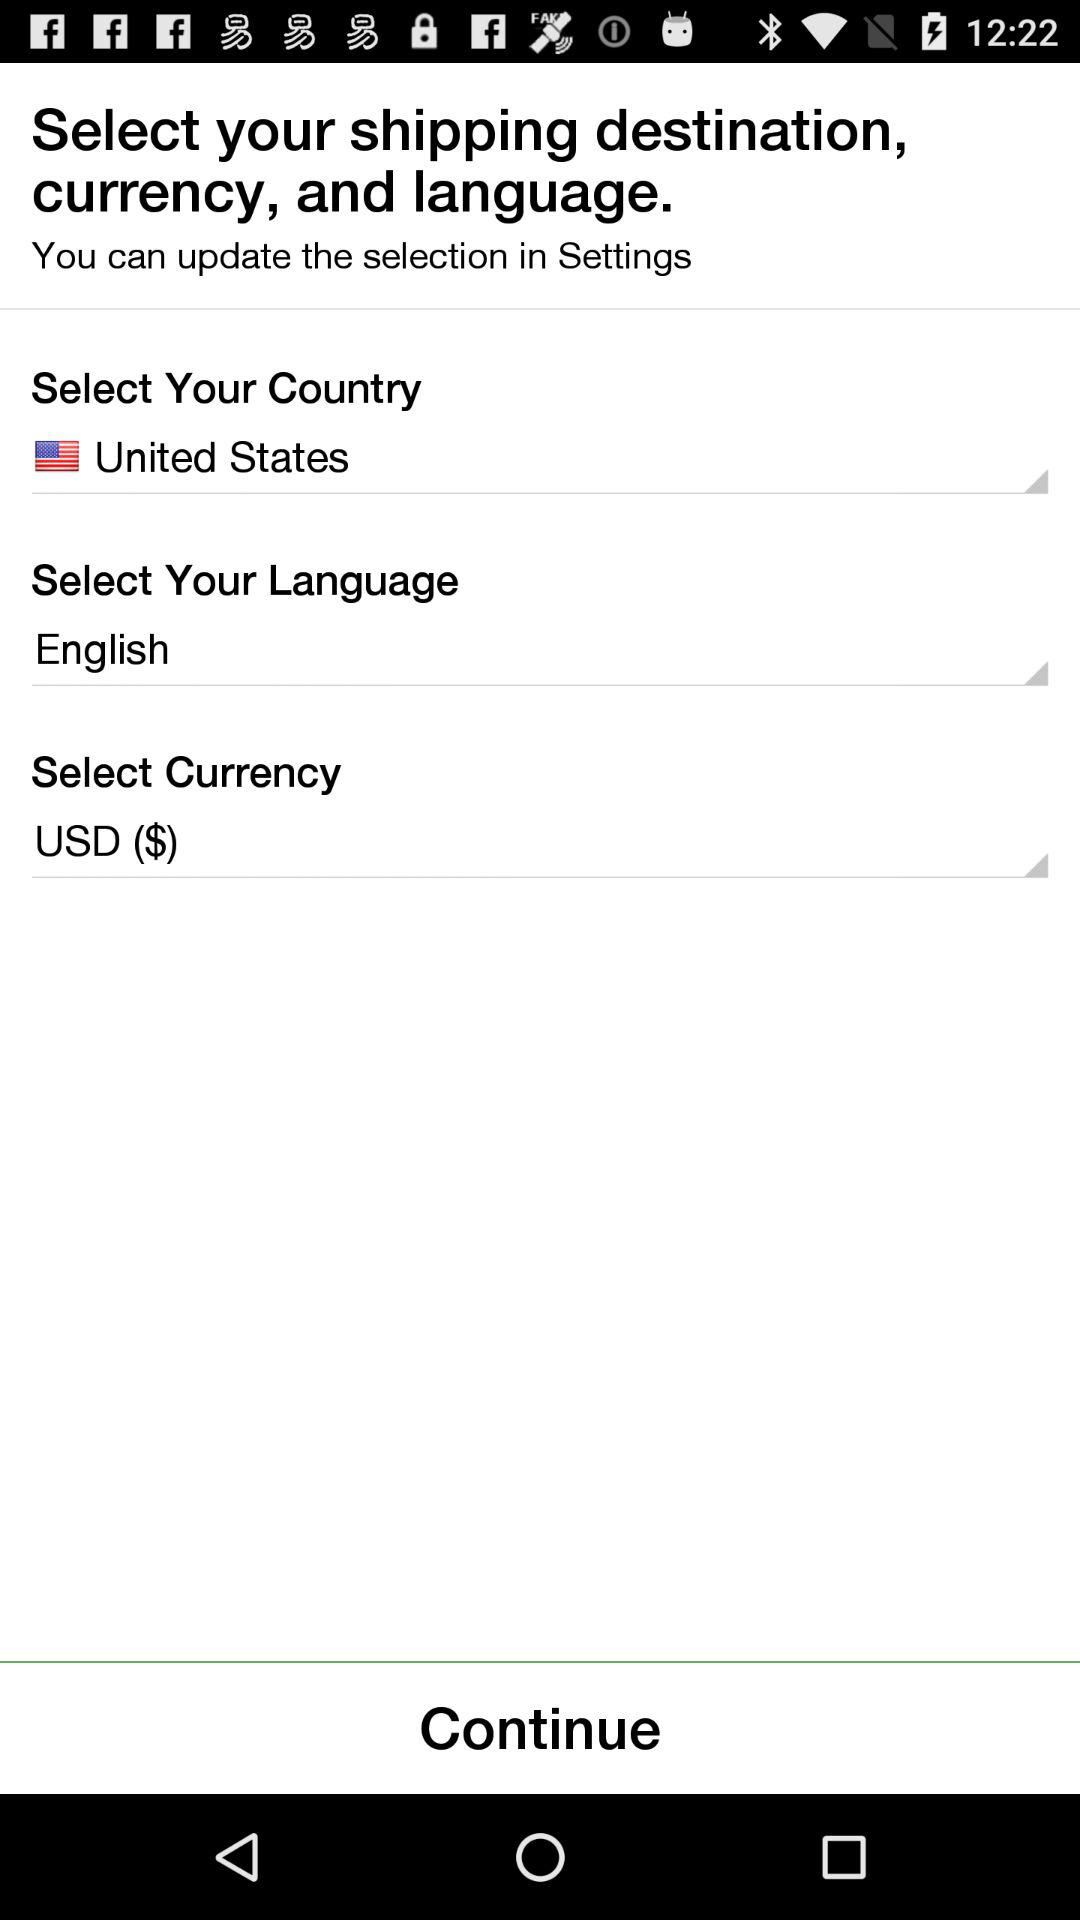What language is selected? The selected language is "English". 